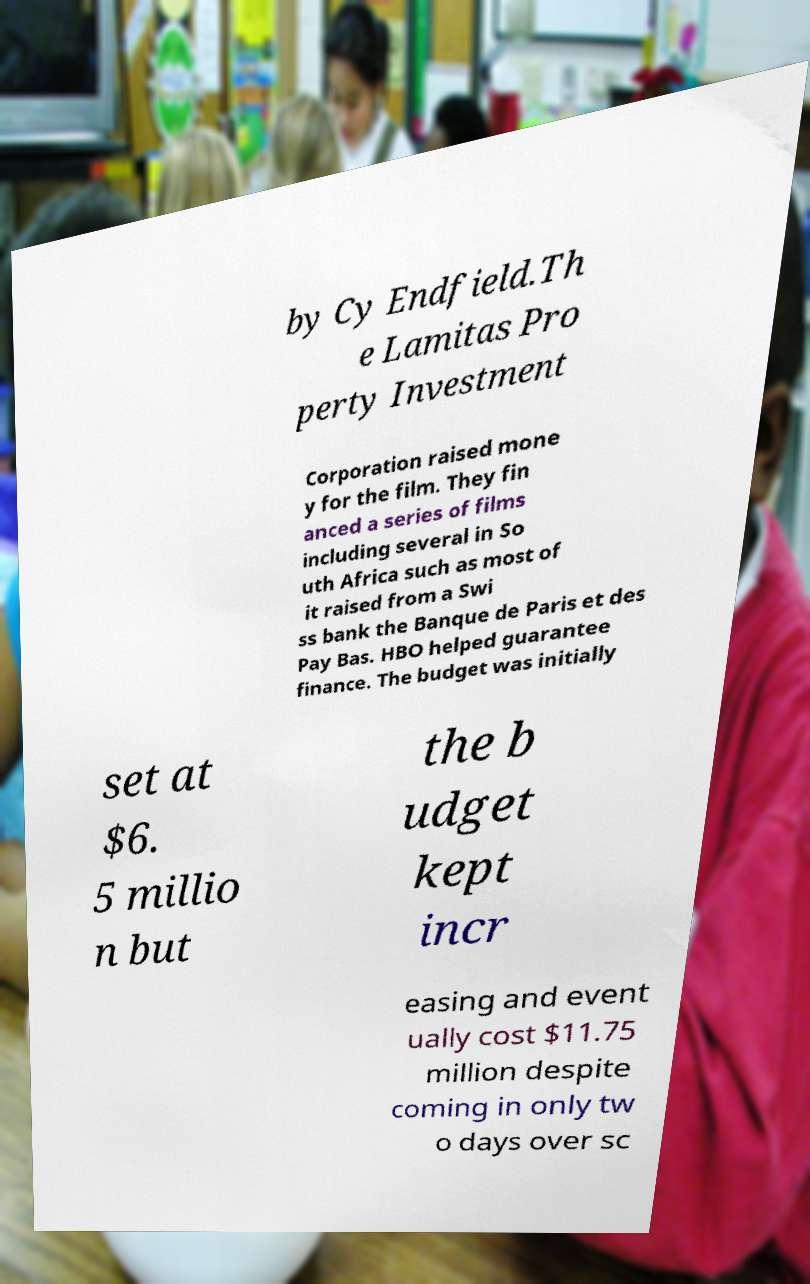Could you assist in decoding the text presented in this image and type it out clearly? by Cy Endfield.Th e Lamitas Pro perty Investment Corporation raised mone y for the film. They fin anced a series of films including several in So uth Africa such as most of it raised from a Swi ss bank the Banque de Paris et des Pay Bas. HBO helped guarantee finance. The budget was initially set at $6. 5 millio n but the b udget kept incr easing and event ually cost $11.75 million despite coming in only tw o days over sc 